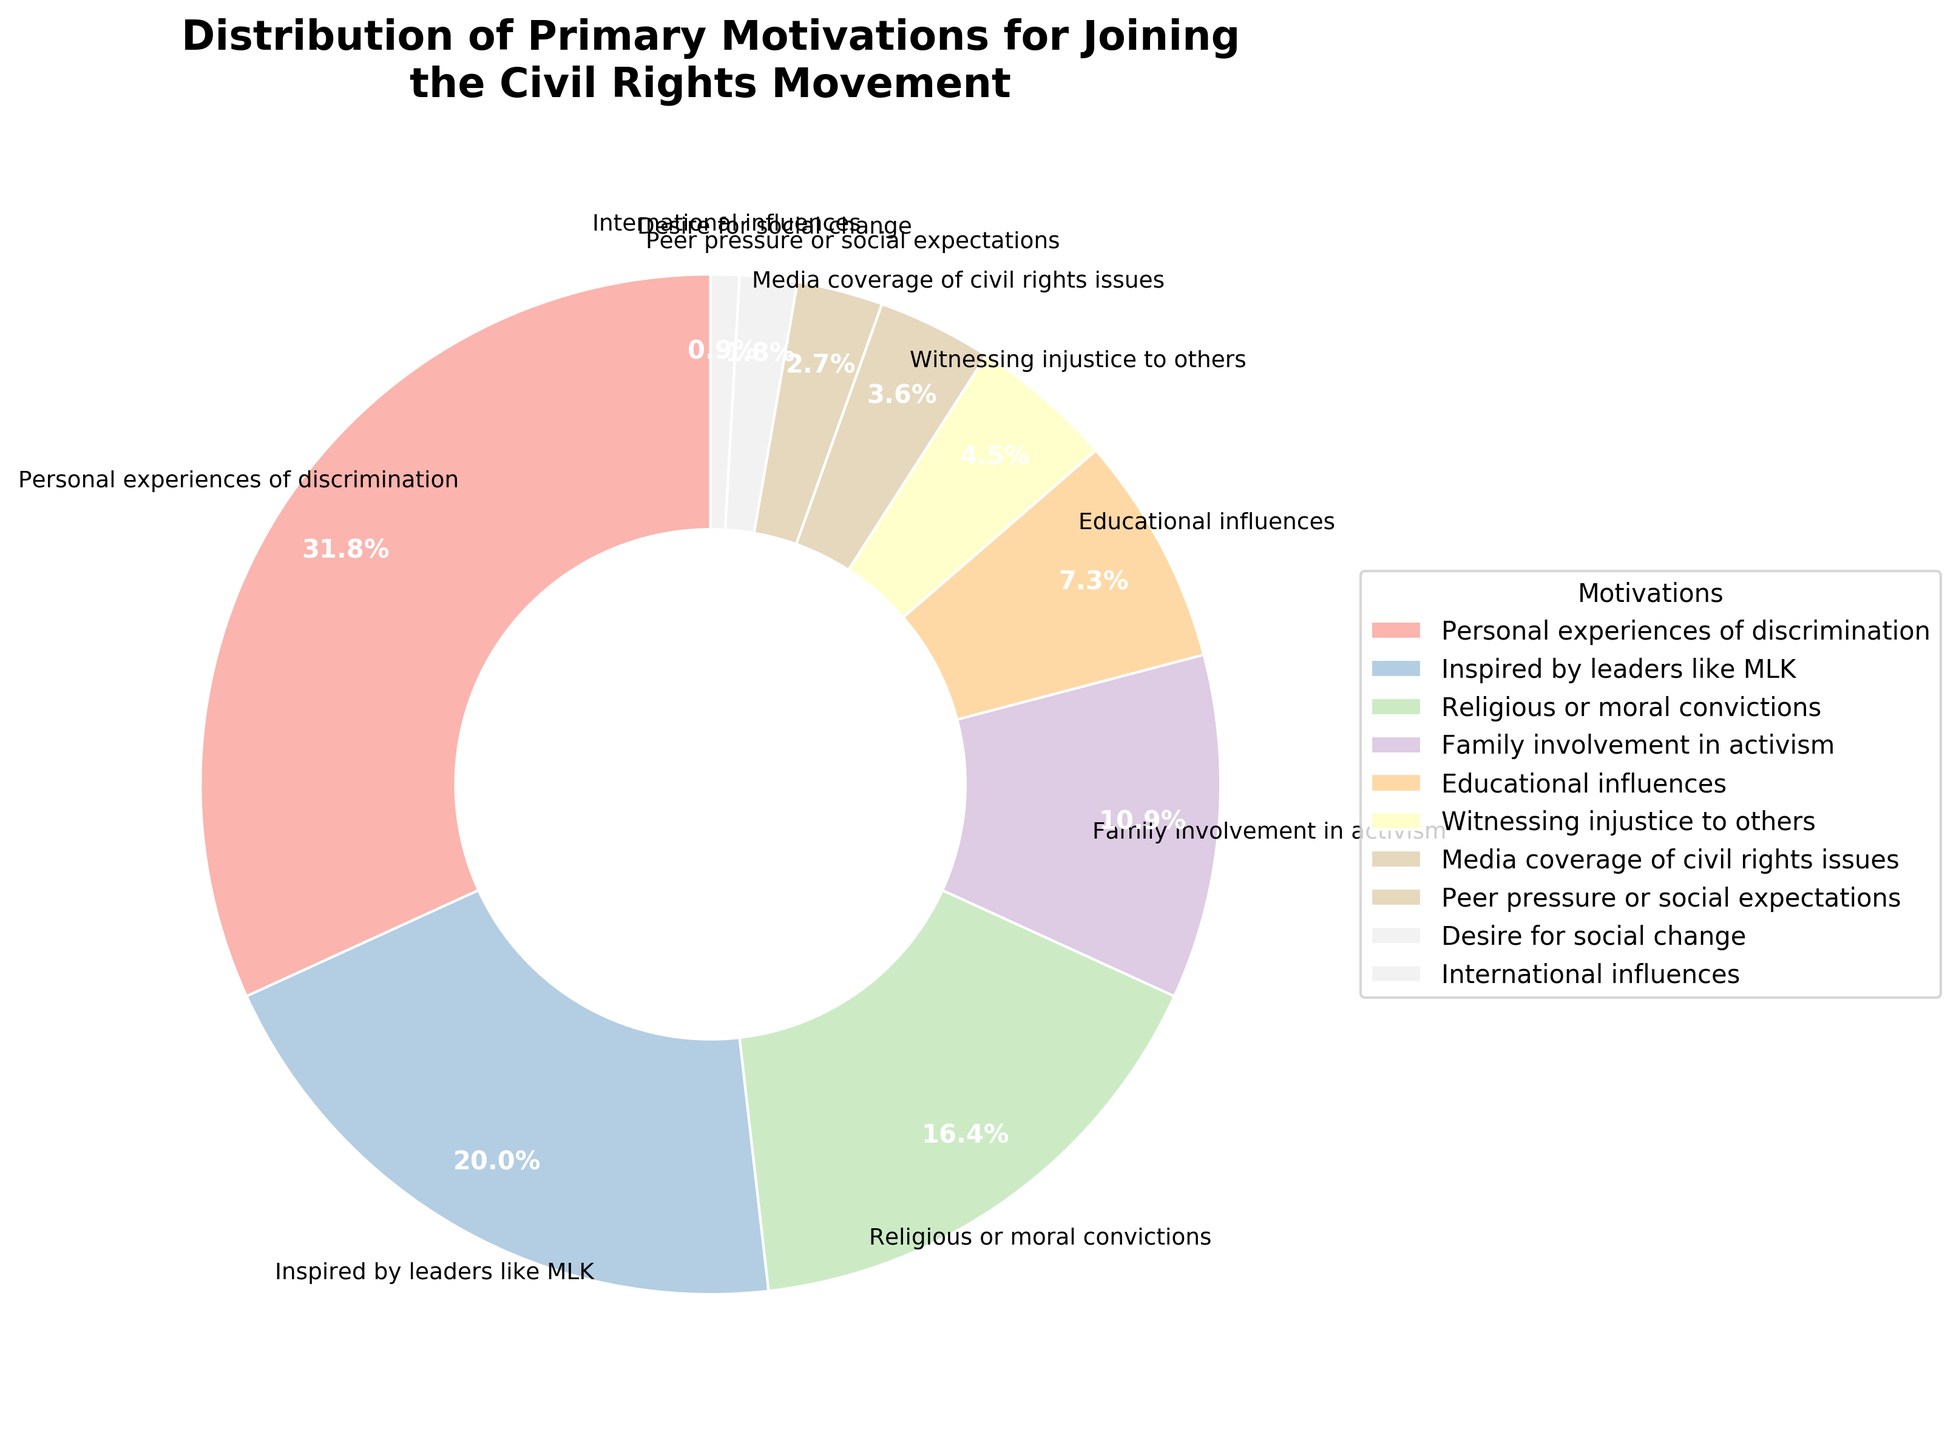What is the most common primary motivation for joining the civil rights movement? Examine the labeled segments of the pie chart to identify which motivation has the largest share. The largest segment is labeled "Personal experiences of discrimination" with 35%.
Answer: Personal experiences of discrimination Which motivation category has a higher percentage: Witnessing injustice to others or Media coverage of civil rights issues? Compare the percentages of the two categories. Witnessing injustice to others has 5%, while Media coverage of civil rights issues has 4%.
Answer: Witnessing injustice to others What is the combined percentage of interviewees whose primary motivation stems from either Family involvement in activism or Educational influences? Add the percentages for Family involvement in activism (12%) and Educational influences (8%) to get the combined percentage. 12% + 8% = 20%
Answer: 20% Out of all the motivations, which one has the smallest percentage and what is it? Look for the smallest labeled segment in the pie chart. The smallest percentage is International influences with 1%.
Answer: International influences Compare the combined percentage of motivations related to inspiration from leaders like MLK and religious or moral convictions with the percentage of those motivated by personal experiences of discrimination. Which is higher? Sum the percentages of Inspired by leaders like MLK (22%) and Religious or moral convictions (18%): 22% + 18% = 40%. Compare this with Personal experiences of discrimination (35%). The combined motivations total 40%, which is higher than 35%.
Answer: Combined motivations (40%) If we group the motivations into broader categories of 'Personal Experience' (includes Personal experiences of discrimination and Witnessing injustice to others) and 'External Influence' (includes Inspired by leaders like MLK, Religious or moral convictions, Family involvement in activism, Educational influences, Media coverage of civil rights issues, Peer pressure or social expectations, Desire for social change, International influences), which group has a higher overall percentage? Sum the percentages for 'Personal Experience' and compare it with the sum for 'External Influence'. Personal experiences of discrimination (35%) + Witnessing injustice to others (5%) = 40%. Sum of external influences is 60% (remaining motivations). 'External Influence' (60%) is higher than 'Personal Experience' (40%).
Answer: External Influence How much higher is the percentage of interviewees motivated by Personal experiences of discrimination compared to those motivated by Peer pressure or social expectations? Subtract the percentage of Peer pressure or social expectations (3%) from Personal experiences of discrimination (35%). 35% - 3% = 32%
Answer: 32% What is the second most common motivation for joining the civil rights movement? Identify the segment with the second largest percentage after the largest one. Inspired by leaders like MLK is the second largest with 22%.
Answer: Inspired by leaders like MLK If we subtract the percentage of those inspired by religious or moral convictions from those inspired by leaders like MLK, what do we get? Subtract the percentage of Religious or moral convictions (18%) from Inspired by leaders like MLK (22%). 22% - 18% = 4%
Answer: 4% What is the total percentage of motivations that fall below 10% each? Sum the percentages of Family involvement in activism (12%), Educational influences (8%), Witnessing injustice to others (5%), Media coverage of civil rights issues (4%), Peer pressure or social expectations (3%), Desire for social change (2%), and International influences (1%). 12% + 8% + 5% + 4% + 3% + 2% + 1% = 25%. Only motivations below 10%: Witnessing injustice to others (5%), Media coverage of civil rights issues (4%), Peer pressure or social expectations (3%), Desire for social change (2%), International influences (1%) = 15%
Answer: 15% 